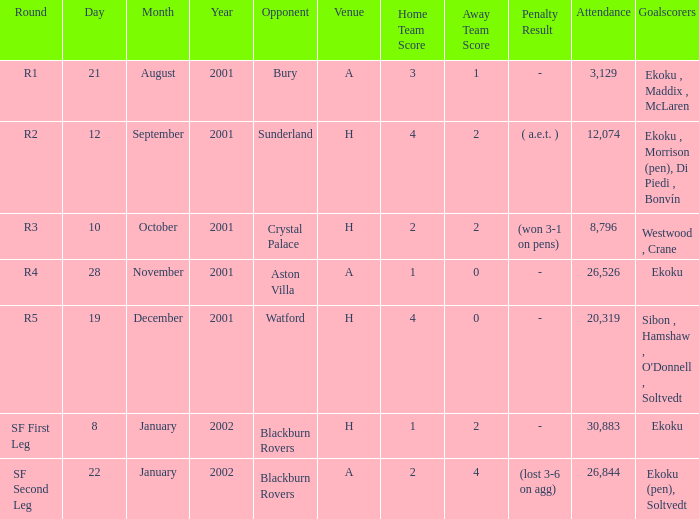Which result has sunderland as opponent? 4–2 ( a.e.t. ). 